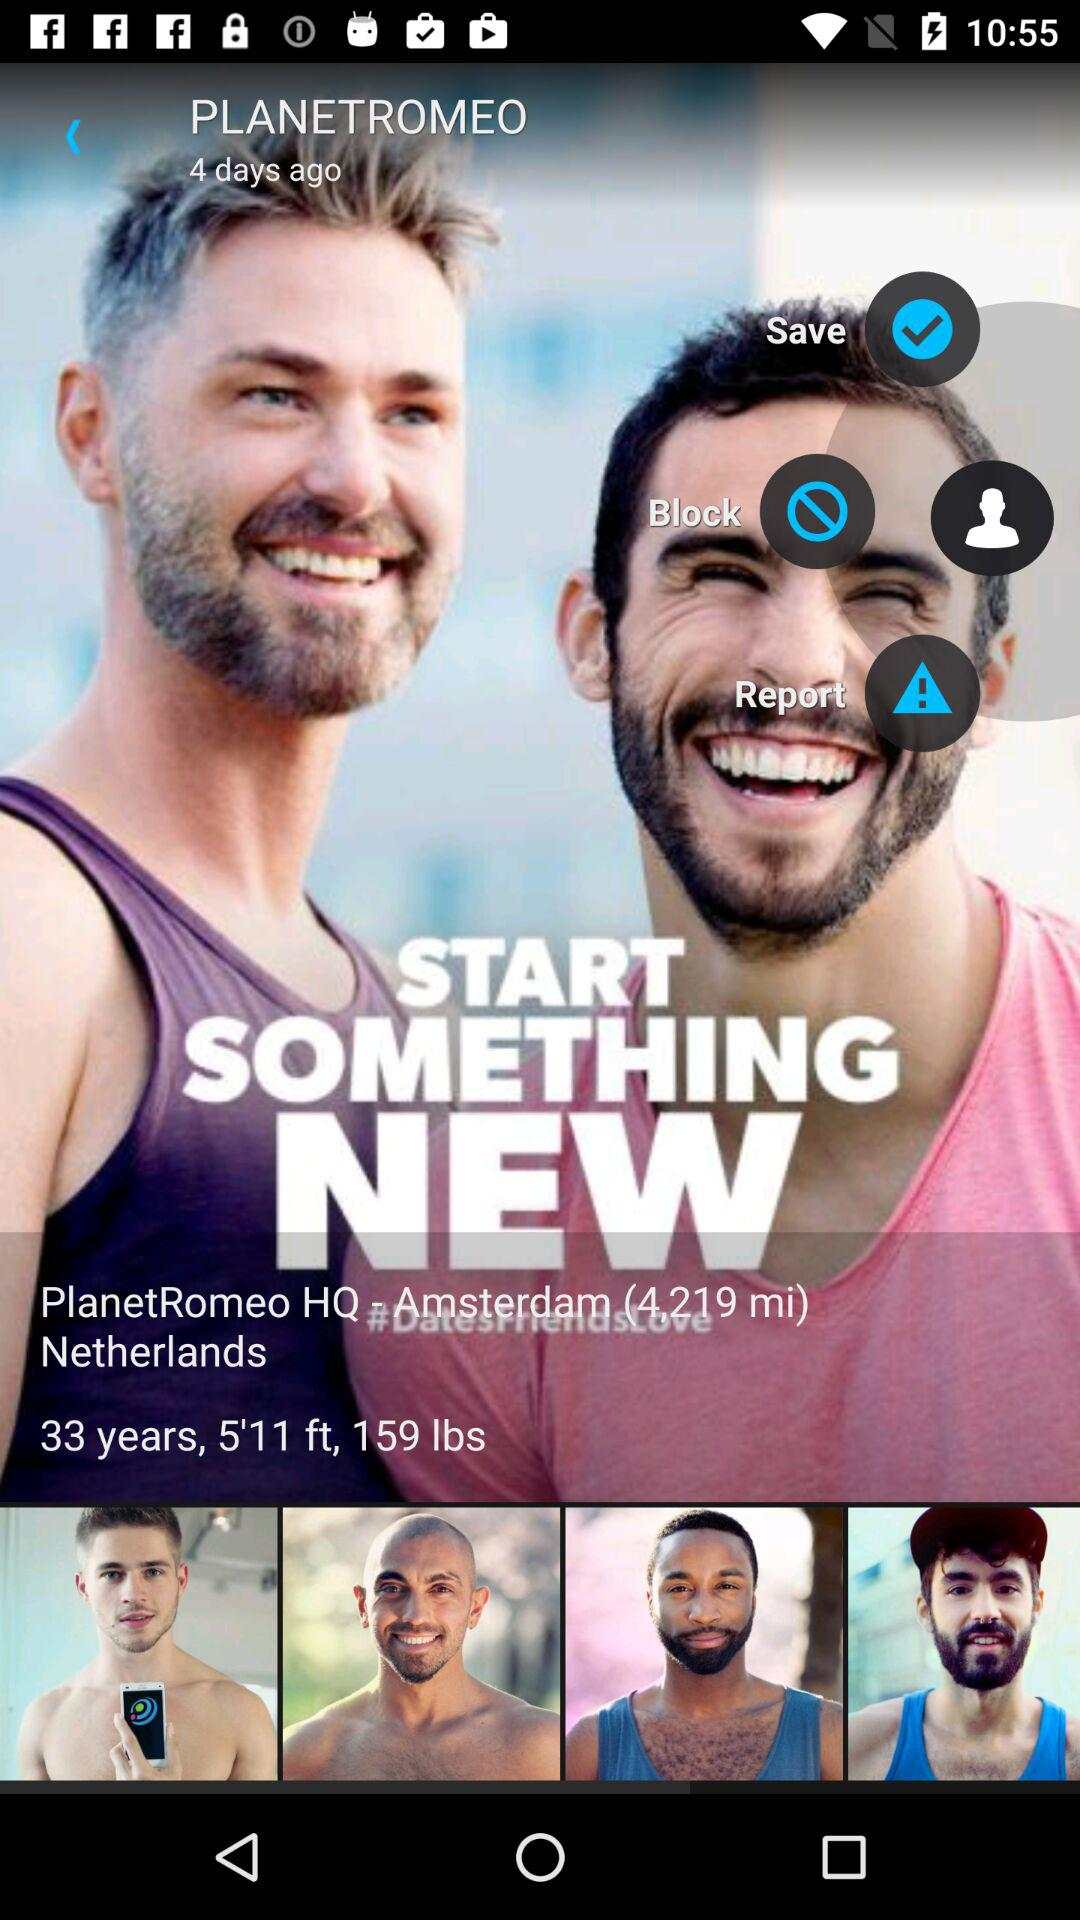What is the height? The height is 5 feet 11 inches. 